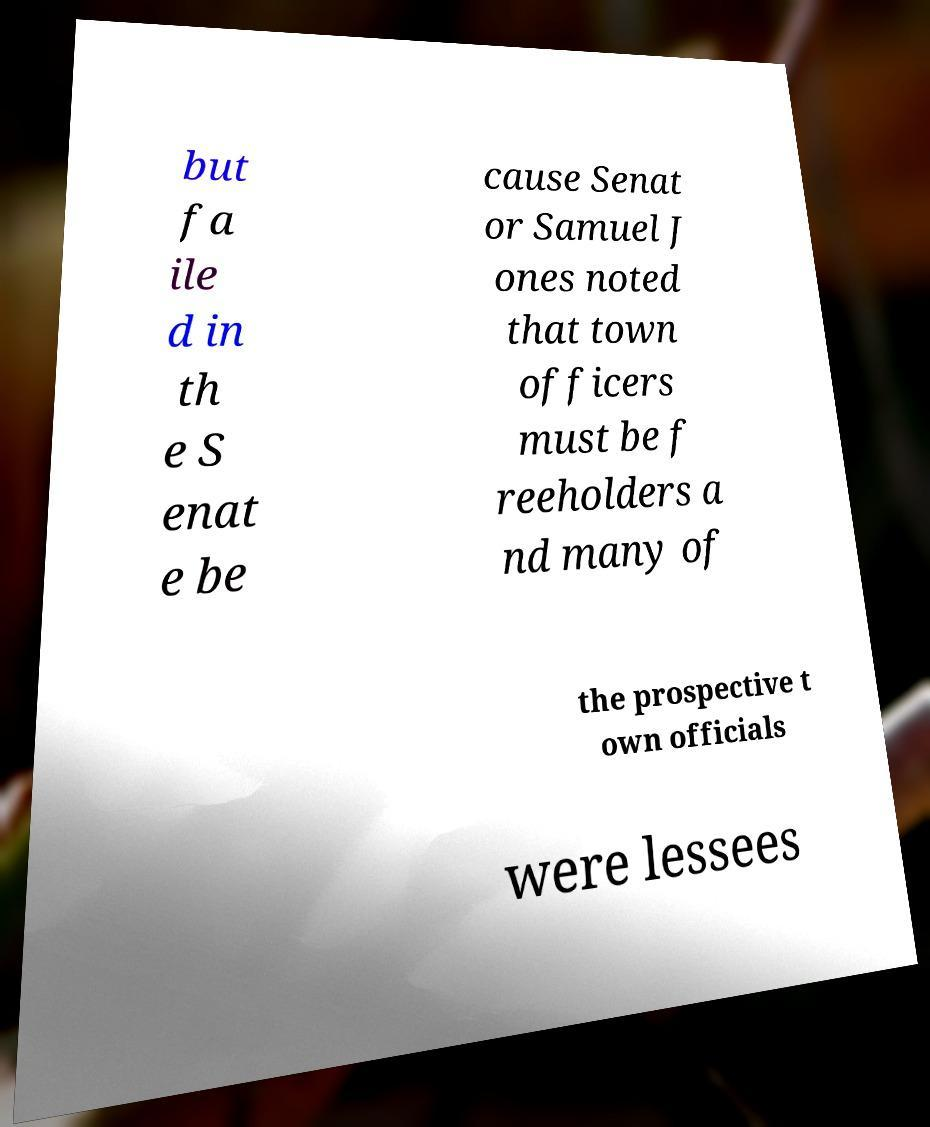For documentation purposes, I need the text within this image transcribed. Could you provide that? but fa ile d in th e S enat e be cause Senat or Samuel J ones noted that town officers must be f reeholders a nd many of the prospective t own officials were lessees 